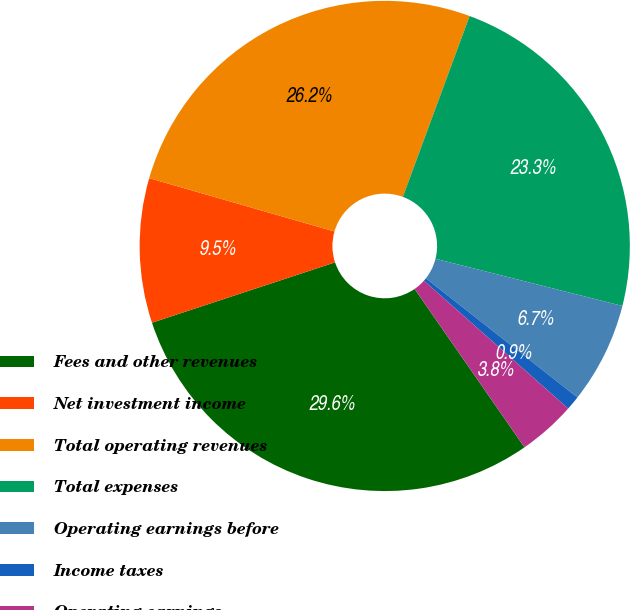Convert chart. <chart><loc_0><loc_0><loc_500><loc_500><pie_chart><fcel>Fees and other revenues<fcel>Net investment income<fcel>Total operating revenues<fcel>Total expenses<fcel>Operating earnings before<fcel>Income taxes<fcel>Operating earnings<nl><fcel>29.59%<fcel>9.53%<fcel>26.17%<fcel>23.31%<fcel>6.67%<fcel>0.94%<fcel>3.8%<nl></chart> 